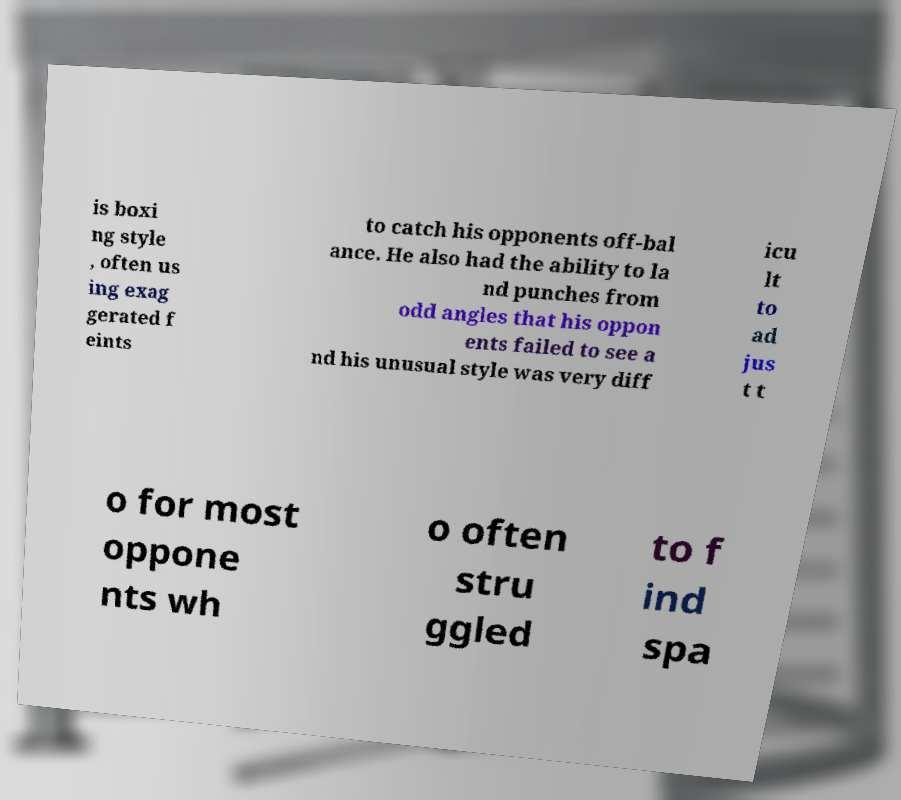Could you extract and type out the text from this image? is boxi ng style , often us ing exag gerated f eints to catch his opponents off-bal ance. He also had the ability to la nd punches from odd angles that his oppon ents failed to see a nd his unusual style was very diff icu lt to ad jus t t o for most oppone nts wh o often stru ggled to f ind spa 